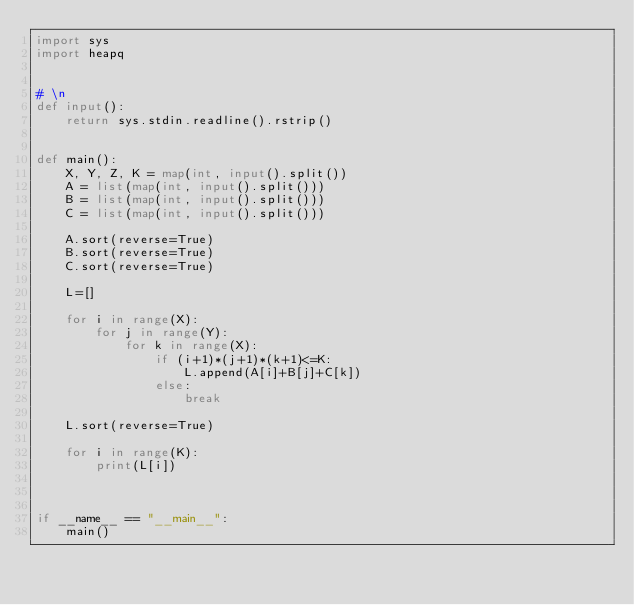Convert code to text. <code><loc_0><loc_0><loc_500><loc_500><_Python_>import sys
import heapq


# \n
def input():
    return sys.stdin.readline().rstrip()


def main():
    X, Y, Z, K = map(int, input().split())
    A = list(map(int, input().split()))
    B = list(map(int, input().split()))
    C = list(map(int, input().split()))

    A.sort(reverse=True)
    B.sort(reverse=True)
    C.sort(reverse=True)

    L=[]

    for i in range(X):
        for j in range(Y):
            for k in range(X):
                if (i+1)*(j+1)*(k+1)<=K:
                    L.append(A[i]+B[j]+C[k])
                else:
                    break

    L.sort(reverse=True)

    for i in range(K):
        print(L[i])



if __name__ == "__main__":
    main()
</code> 